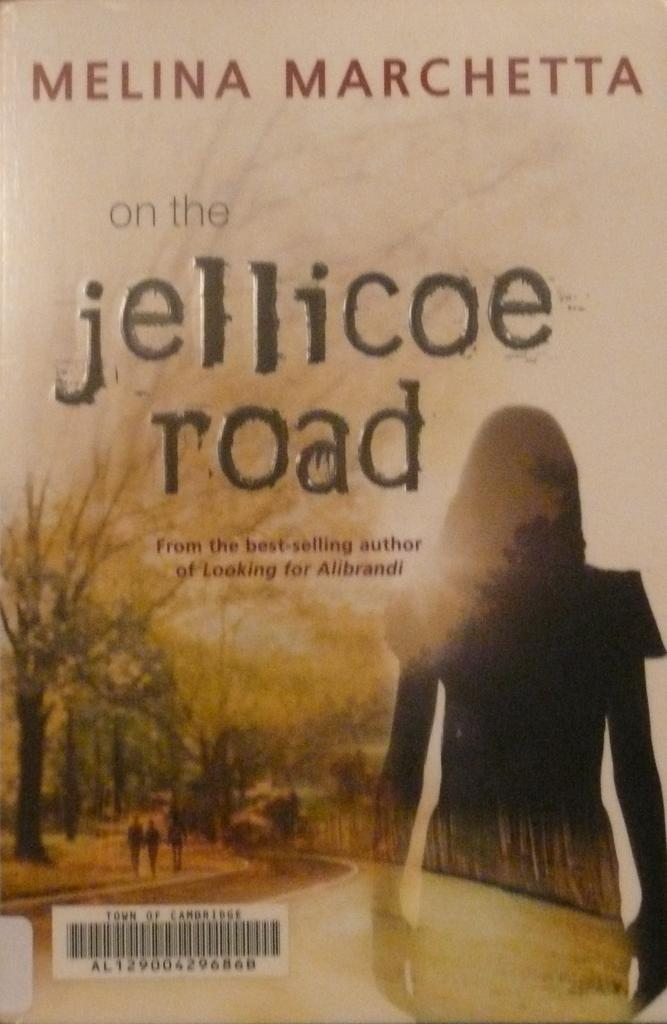<image>
Provide a brief description of the given image. A copy of the book On The Jellicoe Road by Melina Marchetta. 